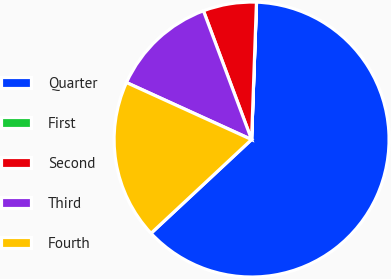Convert chart. <chart><loc_0><loc_0><loc_500><loc_500><pie_chart><fcel>Quarter<fcel>First<fcel>Second<fcel>Third<fcel>Fourth<nl><fcel>62.48%<fcel>0.01%<fcel>6.26%<fcel>12.5%<fcel>18.75%<nl></chart> 